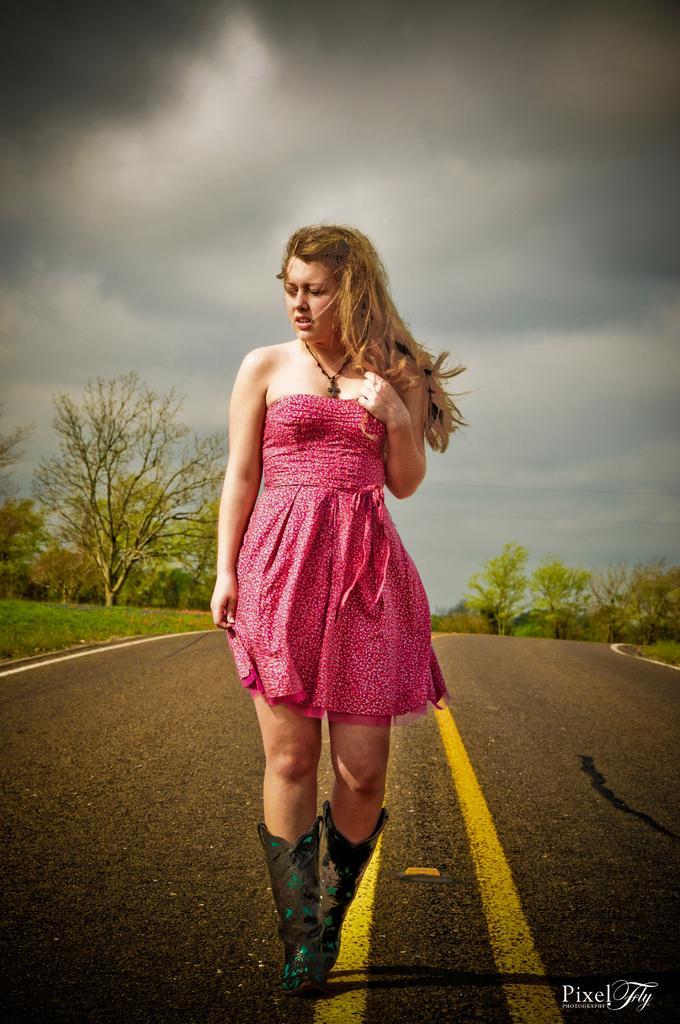Can you describe this image briefly? In front of the picture, we see a woman in the pink dress is stunning. She is posing for the photo. At the bottom, we see the road. On the left side, we see the grass and the trees. There are trees in the background. At the top, we see the sky and the clouds. 